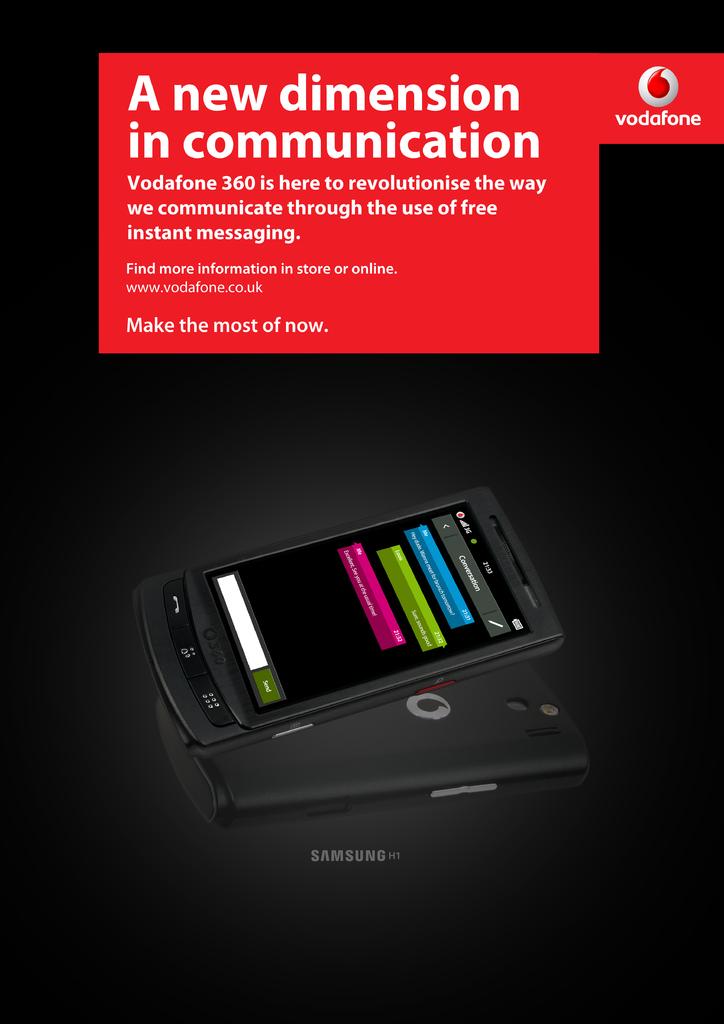What is the new dimension in?
Make the answer very short. Communication. What brand is this?
Provide a succinct answer. Vodafone. 